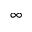<formula> <loc_0><loc_0><loc_500><loc_500>\infty</formula> 